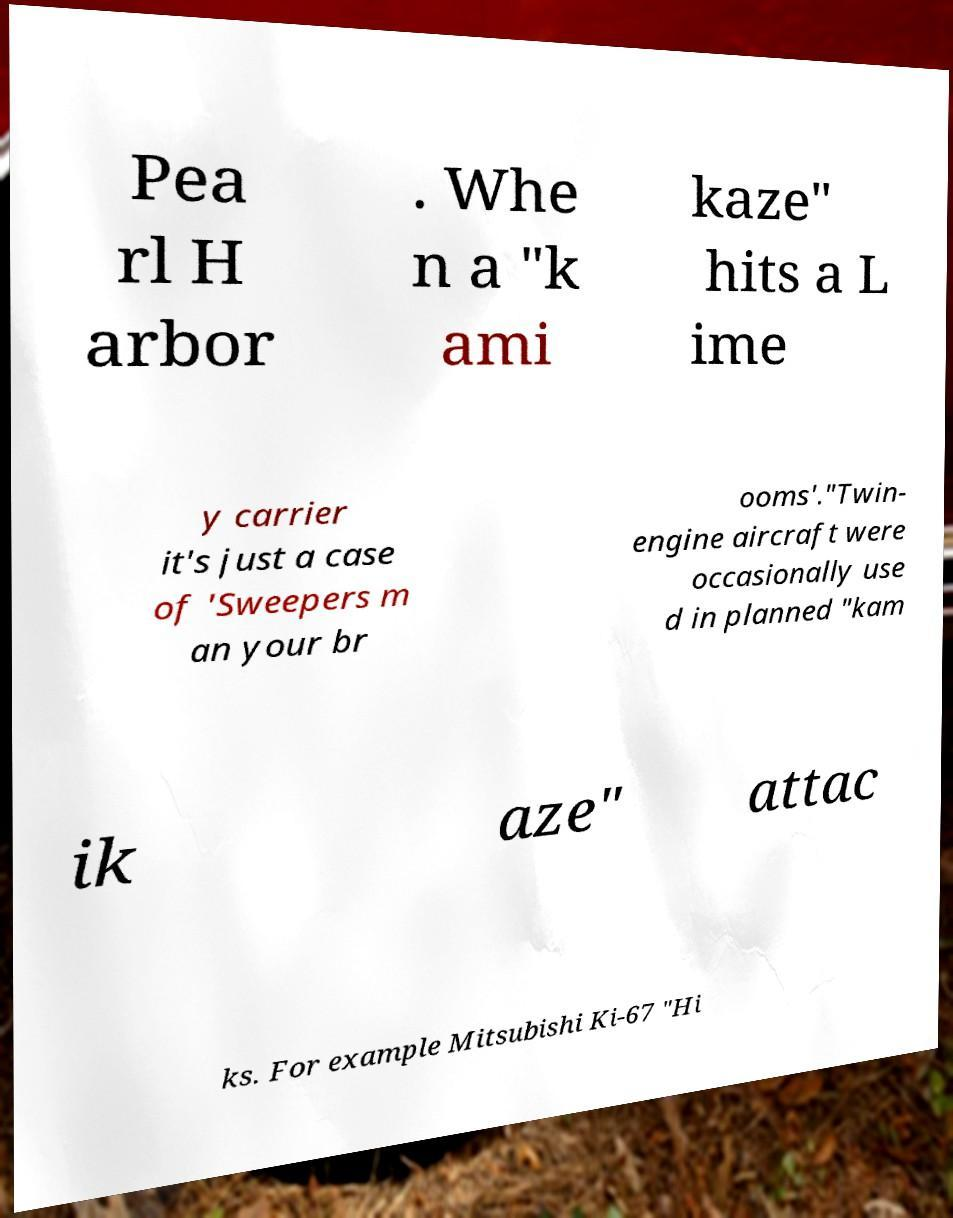I need the written content from this picture converted into text. Can you do that? Pea rl H arbor . Whe n a "k ami kaze" hits a L ime y carrier it's just a case of 'Sweepers m an your br ooms'."Twin- engine aircraft were occasionally use d in planned "kam ik aze" attac ks. For example Mitsubishi Ki-67 "Hi 